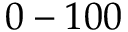Convert formula to latex. <formula><loc_0><loc_0><loc_500><loc_500>0 - 1 0 0</formula> 